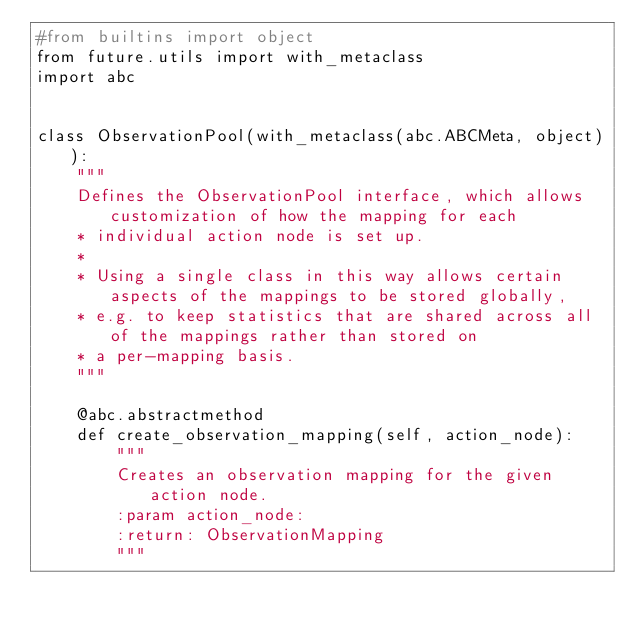Convert code to text. <code><loc_0><loc_0><loc_500><loc_500><_Python_>#from builtins import object
from future.utils import with_metaclass
import abc


class ObservationPool(with_metaclass(abc.ABCMeta, object)):
    """
    Defines the ObservationPool interface, which allows customization of how the mapping for each
    * individual action node is set up.
    *
    * Using a single class in this way allows certain aspects of the mappings to be stored globally,
    * e.g. to keep statistics that are shared across all of the mappings rather than stored on
    * a per-mapping basis.
    """

    @abc.abstractmethod
    def create_observation_mapping(self, action_node):
        """
        Creates an observation mapping for the given action node.
        :param action_node:
        :return: ObservationMapping
        """


</code> 